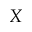Convert formula to latex. <formula><loc_0><loc_0><loc_500><loc_500>X</formula> 